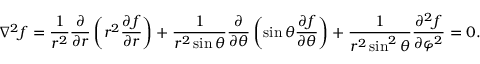Convert formula to latex. <formula><loc_0><loc_0><loc_500><loc_500>\nabla ^ { 2 } f = { \frac { 1 } { r ^ { 2 } } } { \frac { \partial } { \partial r } } \left ( r ^ { 2 } { \frac { \partial f } { \partial r } } \right ) + { \frac { 1 } { r ^ { 2 } \sin \theta } } { \frac { \partial } { \partial \theta } } \left ( \sin \theta { \frac { \partial f } { \partial \theta } } \right ) + { \frac { 1 } { r ^ { 2 } \sin ^ { 2 } \theta } } { \frac { \partial ^ { 2 } f } { \partial \varphi ^ { 2 } } } = 0 .</formula> 